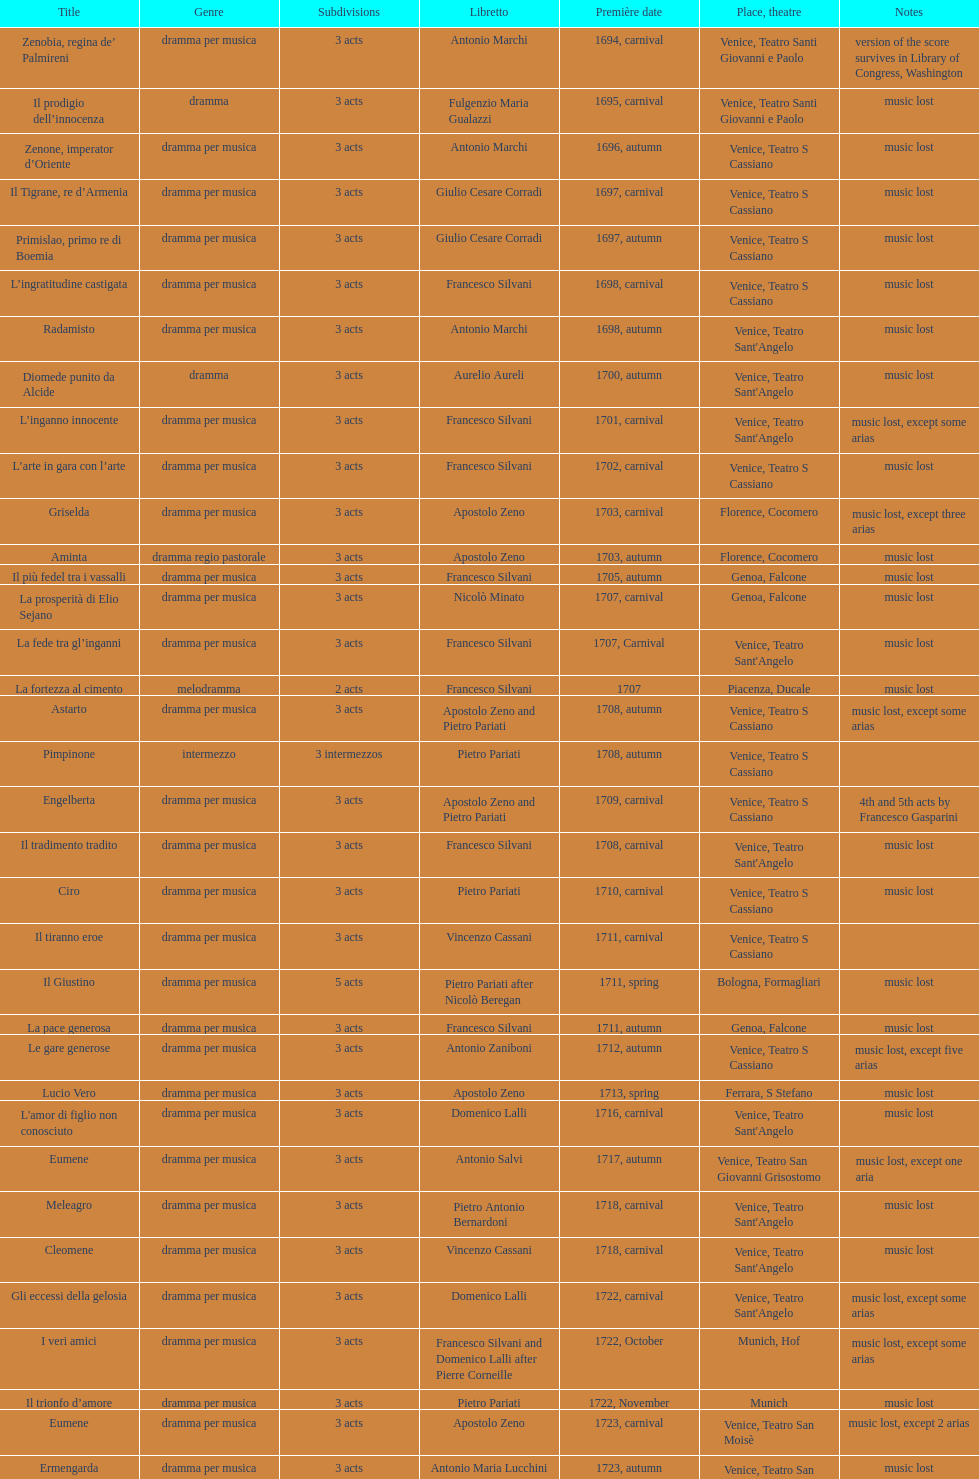Which title premiered directly after candalide? Artamene. 